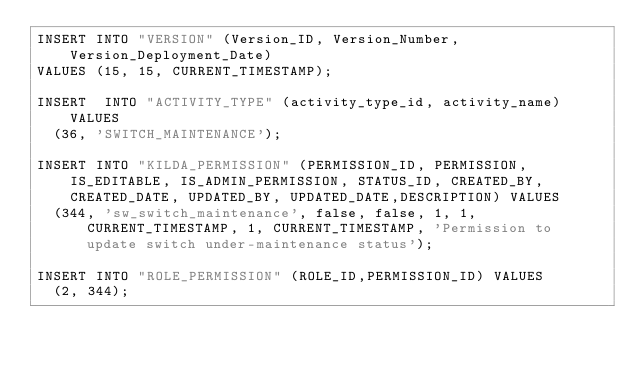<code> <loc_0><loc_0><loc_500><loc_500><_SQL_>INSERT INTO "VERSION" (Version_ID, Version_Number, Version_Deployment_Date)
VALUES (15, 15, CURRENT_TIMESTAMP);
	
INSERT  INTO "ACTIVITY_TYPE" (activity_type_id, activity_name) VALUES 
	(36, 'SWITCH_MAINTENANCE');

INSERT INTO "KILDA_PERMISSION" (PERMISSION_ID, PERMISSION, IS_EDITABLE, IS_ADMIN_PERMISSION, STATUS_ID, CREATED_BY, CREATED_DATE, UPDATED_BY, UPDATED_DATE,DESCRIPTION) VALUES 
	(344, 'sw_switch_maintenance', false, false, 1, 1, CURRENT_TIMESTAMP, 1, CURRENT_TIMESTAMP, 'Permission to update switch under-maintenance status');
	
INSERT INTO "ROLE_PERMISSION" (ROLE_ID,PERMISSION_ID) VALUES 
	(2, 344);</code> 